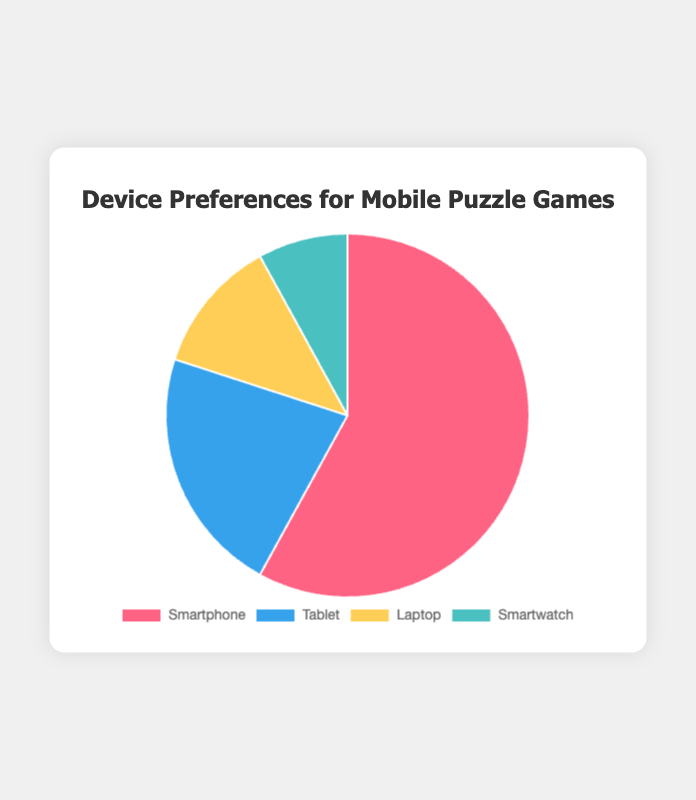Which device is preferred the most for playing mobile puzzle games? The device with the largest percentage in the pie chart is the most preferred. The segment labeled "Smartphone" has a 58% share, which is the highest percentage in the chart.
Answer: Smartphone How does the percentage of tablet users compare to that of laptop users? We compare the two percentages directly from the chart. Tablet users are at 22%, while laptop users are at 12%. Comparing these, 22% is greater than 12%.
Answer: Tablet users are more What is the combined percentage of users who prefer playing on a laptop or smartwatch? Add the percentages of laptop and smartwatch users: 12% (Laptop) + 8% (Smartwatch) = 20%.
Answer: 20% Which device category has the smallest user preference? The segment with the smallest percentage represents the smallest user preference. The pie chart shows that smartwatch users have an 8% share, which is the smallest.
Answer: Smartwatch What is the difference in percentage between smartphone and tablet users? Subtract the percentage of tablet users from smartphone users: 58% (Smartphone) - 22% (Tablet) = 36%.
Answer: 36% If you want to target the majority of the users, which device should you focus on? The majority is represented by the device with more than half of the total percentage. The smartphone has 58%, which is more than half.
Answer: Smartphone What percentage of users do not prefer smartphones? Subtract the percentage of smartphone users from 100% to find the percentage not preferring smartphones: 100% - 58% = 42%.
Answer: 42% What is the median percentage across the four device preferences? Arrange the percentages in ascending order (8%, 12%, 22%, 58%) and find the median. With four values, the median is the average of the two middle numbers: (12% + 22%) / 2 = 17%.
Answer: 17% Between laptop and smartwatch users, which group has fewer users and by what percentage? Compare the percentages: laptop users (12%) and smartwatch users (8%). Smartwatch users are fewer. The difference is 12% - 8% = 4%.
Answer: Smartwatch by 4% What percentage of users prefer playing on devices other than smartwatches? The percentage for smartwatches is 8%. Subtract this from 100% to find the percentage for the others: 100% - 8% = 92%.
Answer: 92% 